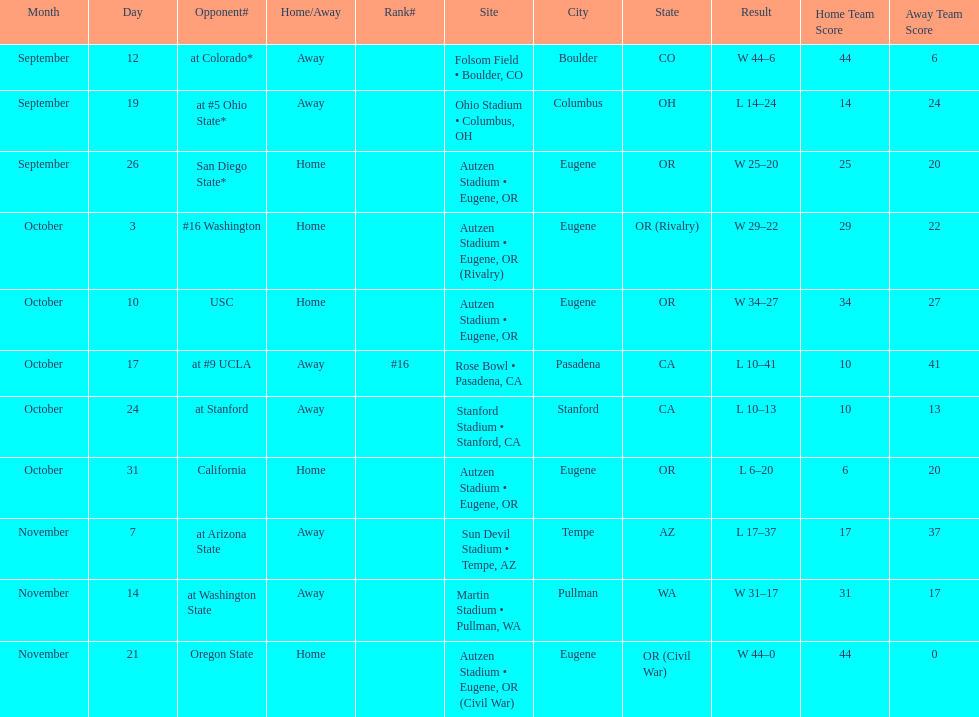What is the number of away games ? 6. 